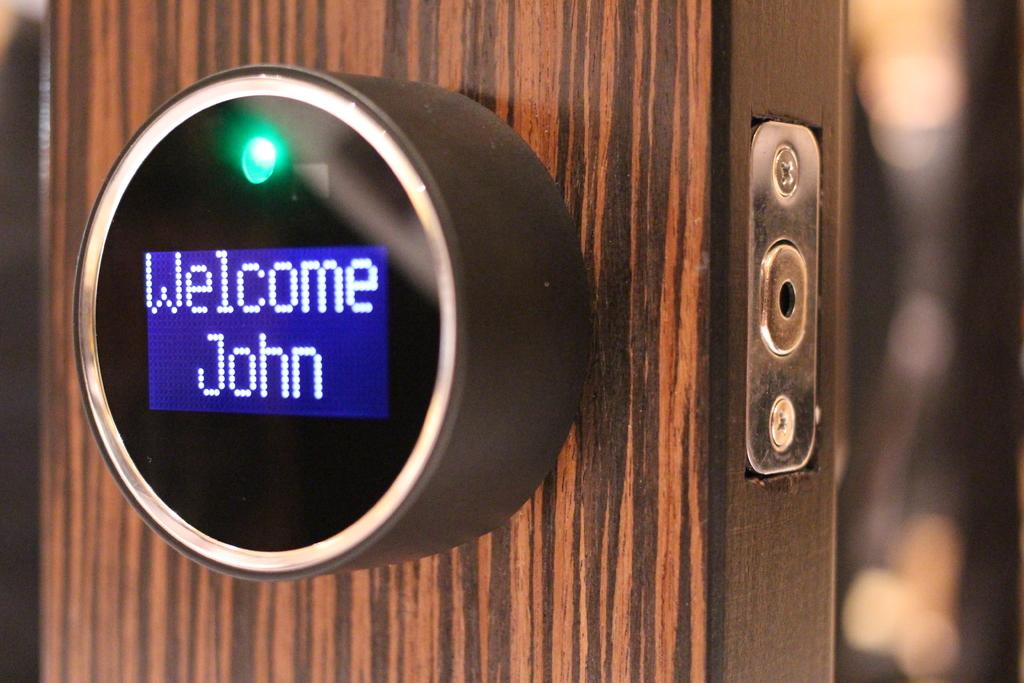<image>
Write a terse but informative summary of the picture. A round silver digital device reads "Welcome John". 